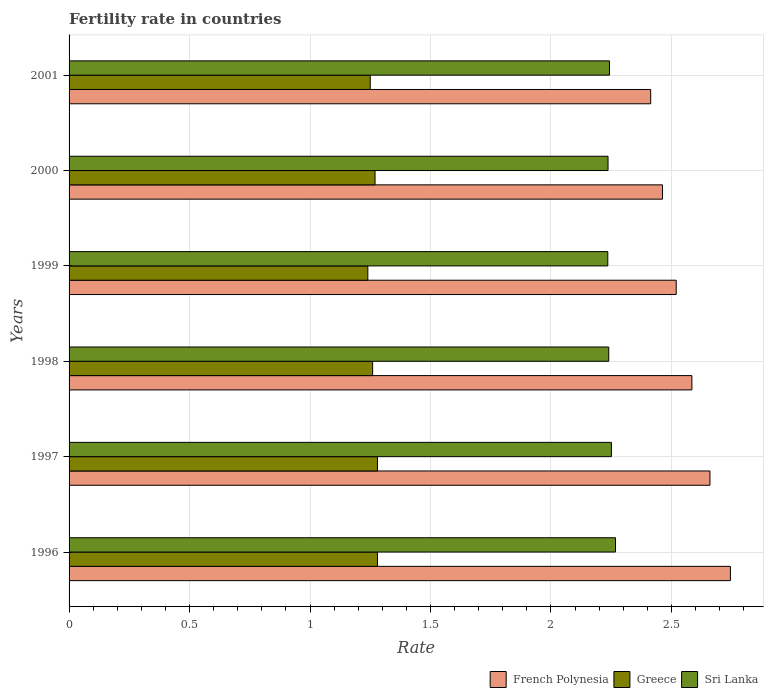Are the number of bars on each tick of the Y-axis equal?
Your answer should be compact. Yes. How many bars are there on the 4th tick from the bottom?
Make the answer very short. 3. What is the label of the 6th group of bars from the top?
Provide a succinct answer. 1996. In how many cases, is the number of bars for a given year not equal to the number of legend labels?
Your answer should be compact. 0. What is the fertility rate in French Polynesia in 1999?
Make the answer very short. 2.52. Across all years, what is the maximum fertility rate in Sri Lanka?
Offer a very short reply. 2.27. Across all years, what is the minimum fertility rate in French Polynesia?
Provide a succinct answer. 2.41. In which year was the fertility rate in Sri Lanka maximum?
Your answer should be very brief. 1996. What is the total fertility rate in Sri Lanka in the graph?
Your answer should be compact. 13.48. What is the difference between the fertility rate in Greece in 1997 and that in 2001?
Your response must be concise. 0.03. What is the difference between the fertility rate in Sri Lanka in 1996 and the fertility rate in French Polynesia in 1999?
Your answer should be compact. -0.25. What is the average fertility rate in Sri Lanka per year?
Your response must be concise. 2.25. In the year 1999, what is the difference between the fertility rate in French Polynesia and fertility rate in Greece?
Provide a succinct answer. 1.28. In how many years, is the fertility rate in French Polynesia greater than 1 ?
Keep it short and to the point. 6. What is the ratio of the fertility rate in French Polynesia in 1996 to that in 2001?
Provide a short and direct response. 1.14. Is the difference between the fertility rate in French Polynesia in 1997 and 2001 greater than the difference between the fertility rate in Greece in 1997 and 2001?
Offer a terse response. Yes. What is the difference between the highest and the second highest fertility rate in Greece?
Keep it short and to the point. 0. What is the difference between the highest and the lowest fertility rate in Greece?
Ensure brevity in your answer.  0.04. What does the 2nd bar from the top in 1997 represents?
Offer a terse response. Greece. What does the 3rd bar from the bottom in 1998 represents?
Your response must be concise. Sri Lanka. Are all the bars in the graph horizontal?
Offer a terse response. Yes. Does the graph contain any zero values?
Offer a very short reply. No. Does the graph contain grids?
Make the answer very short. Yes. How many legend labels are there?
Your answer should be compact. 3. What is the title of the graph?
Give a very brief answer. Fertility rate in countries. What is the label or title of the X-axis?
Make the answer very short. Rate. What is the label or title of the Y-axis?
Your answer should be compact. Years. What is the Rate in French Polynesia in 1996?
Your answer should be compact. 2.75. What is the Rate of Greece in 1996?
Provide a succinct answer. 1.28. What is the Rate of Sri Lanka in 1996?
Provide a short and direct response. 2.27. What is the Rate of French Polynesia in 1997?
Ensure brevity in your answer.  2.66. What is the Rate in Greece in 1997?
Provide a short and direct response. 1.28. What is the Rate of Sri Lanka in 1997?
Offer a very short reply. 2.25. What is the Rate in French Polynesia in 1998?
Provide a succinct answer. 2.58. What is the Rate of Greece in 1998?
Ensure brevity in your answer.  1.26. What is the Rate in Sri Lanka in 1998?
Give a very brief answer. 2.24. What is the Rate in French Polynesia in 1999?
Your answer should be compact. 2.52. What is the Rate of Greece in 1999?
Your answer should be compact. 1.24. What is the Rate in Sri Lanka in 1999?
Keep it short and to the point. 2.24. What is the Rate in French Polynesia in 2000?
Make the answer very short. 2.46. What is the Rate in Greece in 2000?
Provide a succinct answer. 1.27. What is the Rate in Sri Lanka in 2000?
Provide a short and direct response. 2.24. What is the Rate in French Polynesia in 2001?
Give a very brief answer. 2.41. What is the Rate of Greece in 2001?
Make the answer very short. 1.25. What is the Rate in Sri Lanka in 2001?
Keep it short and to the point. 2.24. Across all years, what is the maximum Rate of French Polynesia?
Your response must be concise. 2.75. Across all years, what is the maximum Rate of Greece?
Offer a very short reply. 1.28. Across all years, what is the maximum Rate in Sri Lanka?
Ensure brevity in your answer.  2.27. Across all years, what is the minimum Rate in French Polynesia?
Your response must be concise. 2.41. Across all years, what is the minimum Rate of Greece?
Your response must be concise. 1.24. Across all years, what is the minimum Rate of Sri Lanka?
Your response must be concise. 2.24. What is the total Rate in French Polynesia in the graph?
Provide a succinct answer. 15.39. What is the total Rate in Greece in the graph?
Offer a very short reply. 7.58. What is the total Rate in Sri Lanka in the graph?
Keep it short and to the point. 13.47. What is the difference between the Rate in French Polynesia in 1996 and that in 1997?
Your answer should be very brief. 0.09. What is the difference between the Rate of Sri Lanka in 1996 and that in 1997?
Your answer should be compact. 0.02. What is the difference between the Rate of French Polynesia in 1996 and that in 1998?
Offer a very short reply. 0.16. What is the difference between the Rate in Sri Lanka in 1996 and that in 1998?
Ensure brevity in your answer.  0.03. What is the difference between the Rate of French Polynesia in 1996 and that in 1999?
Offer a very short reply. 0.23. What is the difference between the Rate in Sri Lanka in 1996 and that in 1999?
Make the answer very short. 0.03. What is the difference between the Rate of French Polynesia in 1996 and that in 2000?
Your answer should be very brief. 0.28. What is the difference between the Rate of Greece in 1996 and that in 2000?
Your answer should be very brief. 0.01. What is the difference between the Rate in Sri Lanka in 1996 and that in 2000?
Offer a very short reply. 0.03. What is the difference between the Rate of French Polynesia in 1996 and that in 2001?
Offer a terse response. 0.33. What is the difference between the Rate in Greece in 1996 and that in 2001?
Your response must be concise. 0.03. What is the difference between the Rate of Sri Lanka in 1996 and that in 2001?
Your response must be concise. 0.03. What is the difference between the Rate of French Polynesia in 1997 and that in 1998?
Give a very brief answer. 0.07. What is the difference between the Rate in Greece in 1997 and that in 1998?
Keep it short and to the point. 0.02. What is the difference between the Rate in Sri Lanka in 1997 and that in 1998?
Your answer should be compact. 0.01. What is the difference between the Rate in French Polynesia in 1997 and that in 1999?
Your answer should be very brief. 0.14. What is the difference between the Rate of Sri Lanka in 1997 and that in 1999?
Offer a very short reply. 0.01. What is the difference between the Rate in French Polynesia in 1997 and that in 2000?
Provide a short and direct response. 0.2. What is the difference between the Rate in Greece in 1997 and that in 2000?
Provide a succinct answer. 0.01. What is the difference between the Rate in Sri Lanka in 1997 and that in 2000?
Ensure brevity in your answer.  0.01. What is the difference between the Rate in French Polynesia in 1997 and that in 2001?
Your answer should be compact. 0.25. What is the difference between the Rate in Greece in 1997 and that in 2001?
Give a very brief answer. 0.03. What is the difference between the Rate in Sri Lanka in 1997 and that in 2001?
Your answer should be very brief. 0.01. What is the difference between the Rate in French Polynesia in 1998 and that in 1999?
Give a very brief answer. 0.07. What is the difference between the Rate in Greece in 1998 and that in 1999?
Your answer should be very brief. 0.02. What is the difference between the Rate of Sri Lanka in 1998 and that in 1999?
Offer a very short reply. 0. What is the difference between the Rate in French Polynesia in 1998 and that in 2000?
Offer a very short reply. 0.12. What is the difference between the Rate of Greece in 1998 and that in 2000?
Ensure brevity in your answer.  -0.01. What is the difference between the Rate of Sri Lanka in 1998 and that in 2000?
Make the answer very short. 0. What is the difference between the Rate of French Polynesia in 1998 and that in 2001?
Your answer should be very brief. 0.17. What is the difference between the Rate in Greece in 1998 and that in 2001?
Offer a terse response. 0.01. What is the difference between the Rate in Sri Lanka in 1998 and that in 2001?
Your answer should be compact. -0. What is the difference between the Rate in French Polynesia in 1999 and that in 2000?
Your response must be concise. 0.06. What is the difference between the Rate of Greece in 1999 and that in 2000?
Provide a short and direct response. -0.03. What is the difference between the Rate of Sri Lanka in 1999 and that in 2000?
Offer a terse response. -0. What is the difference between the Rate of French Polynesia in 1999 and that in 2001?
Keep it short and to the point. 0.11. What is the difference between the Rate of Greece in 1999 and that in 2001?
Give a very brief answer. -0.01. What is the difference between the Rate in Sri Lanka in 1999 and that in 2001?
Your answer should be compact. -0.01. What is the difference between the Rate in French Polynesia in 2000 and that in 2001?
Make the answer very short. 0.05. What is the difference between the Rate of Greece in 2000 and that in 2001?
Give a very brief answer. 0.02. What is the difference between the Rate of Sri Lanka in 2000 and that in 2001?
Provide a succinct answer. -0.01. What is the difference between the Rate in French Polynesia in 1996 and the Rate in Greece in 1997?
Your response must be concise. 1.47. What is the difference between the Rate of French Polynesia in 1996 and the Rate of Sri Lanka in 1997?
Give a very brief answer. 0.49. What is the difference between the Rate in Greece in 1996 and the Rate in Sri Lanka in 1997?
Offer a terse response. -0.97. What is the difference between the Rate in French Polynesia in 1996 and the Rate in Greece in 1998?
Give a very brief answer. 1.49. What is the difference between the Rate in French Polynesia in 1996 and the Rate in Sri Lanka in 1998?
Your response must be concise. 0.51. What is the difference between the Rate of Greece in 1996 and the Rate of Sri Lanka in 1998?
Your response must be concise. -0.96. What is the difference between the Rate in French Polynesia in 1996 and the Rate in Greece in 1999?
Make the answer very short. 1.5. What is the difference between the Rate in French Polynesia in 1996 and the Rate in Sri Lanka in 1999?
Offer a terse response. 0.51. What is the difference between the Rate of Greece in 1996 and the Rate of Sri Lanka in 1999?
Your response must be concise. -0.96. What is the difference between the Rate in French Polynesia in 1996 and the Rate in Greece in 2000?
Give a very brief answer. 1.48. What is the difference between the Rate in French Polynesia in 1996 and the Rate in Sri Lanka in 2000?
Provide a short and direct response. 0.51. What is the difference between the Rate of Greece in 1996 and the Rate of Sri Lanka in 2000?
Provide a succinct answer. -0.96. What is the difference between the Rate in French Polynesia in 1996 and the Rate in Greece in 2001?
Your answer should be very brief. 1.5. What is the difference between the Rate in French Polynesia in 1996 and the Rate in Sri Lanka in 2001?
Your response must be concise. 0.5. What is the difference between the Rate of Greece in 1996 and the Rate of Sri Lanka in 2001?
Your answer should be compact. -0.96. What is the difference between the Rate in French Polynesia in 1997 and the Rate in Greece in 1998?
Keep it short and to the point. 1.4. What is the difference between the Rate of French Polynesia in 1997 and the Rate of Sri Lanka in 1998?
Provide a short and direct response. 0.42. What is the difference between the Rate of Greece in 1997 and the Rate of Sri Lanka in 1998?
Make the answer very short. -0.96. What is the difference between the Rate of French Polynesia in 1997 and the Rate of Greece in 1999?
Your response must be concise. 1.42. What is the difference between the Rate of French Polynesia in 1997 and the Rate of Sri Lanka in 1999?
Give a very brief answer. 0.42. What is the difference between the Rate in Greece in 1997 and the Rate in Sri Lanka in 1999?
Your response must be concise. -0.96. What is the difference between the Rate in French Polynesia in 1997 and the Rate in Greece in 2000?
Your answer should be very brief. 1.39. What is the difference between the Rate in French Polynesia in 1997 and the Rate in Sri Lanka in 2000?
Your response must be concise. 0.42. What is the difference between the Rate of Greece in 1997 and the Rate of Sri Lanka in 2000?
Your answer should be compact. -0.96. What is the difference between the Rate in French Polynesia in 1997 and the Rate in Greece in 2001?
Provide a succinct answer. 1.41. What is the difference between the Rate in French Polynesia in 1997 and the Rate in Sri Lanka in 2001?
Make the answer very short. 0.42. What is the difference between the Rate of Greece in 1997 and the Rate of Sri Lanka in 2001?
Make the answer very short. -0.96. What is the difference between the Rate of French Polynesia in 1998 and the Rate of Greece in 1999?
Provide a short and direct response. 1.34. What is the difference between the Rate of French Polynesia in 1998 and the Rate of Sri Lanka in 1999?
Offer a very short reply. 0.35. What is the difference between the Rate in Greece in 1998 and the Rate in Sri Lanka in 1999?
Offer a very short reply. -0.98. What is the difference between the Rate in French Polynesia in 1998 and the Rate in Greece in 2000?
Make the answer very short. 1.31. What is the difference between the Rate of French Polynesia in 1998 and the Rate of Sri Lanka in 2000?
Offer a very short reply. 0.35. What is the difference between the Rate of Greece in 1998 and the Rate of Sri Lanka in 2000?
Your answer should be very brief. -0.98. What is the difference between the Rate in French Polynesia in 1998 and the Rate in Greece in 2001?
Provide a succinct answer. 1.33. What is the difference between the Rate in French Polynesia in 1998 and the Rate in Sri Lanka in 2001?
Keep it short and to the point. 0.34. What is the difference between the Rate in Greece in 1998 and the Rate in Sri Lanka in 2001?
Offer a very short reply. -0.98. What is the difference between the Rate in French Polynesia in 1999 and the Rate in Greece in 2000?
Provide a short and direct response. 1.25. What is the difference between the Rate in French Polynesia in 1999 and the Rate in Sri Lanka in 2000?
Offer a terse response. 0.28. What is the difference between the Rate in Greece in 1999 and the Rate in Sri Lanka in 2000?
Ensure brevity in your answer.  -1. What is the difference between the Rate of French Polynesia in 1999 and the Rate of Greece in 2001?
Offer a terse response. 1.27. What is the difference between the Rate in French Polynesia in 1999 and the Rate in Sri Lanka in 2001?
Your answer should be very brief. 0.28. What is the difference between the Rate in Greece in 1999 and the Rate in Sri Lanka in 2001?
Offer a very short reply. -1. What is the difference between the Rate of French Polynesia in 2000 and the Rate of Greece in 2001?
Keep it short and to the point. 1.21. What is the difference between the Rate in French Polynesia in 2000 and the Rate in Sri Lanka in 2001?
Offer a very short reply. 0.22. What is the difference between the Rate of Greece in 2000 and the Rate of Sri Lanka in 2001?
Your answer should be very brief. -0.97. What is the average Rate in French Polynesia per year?
Offer a very short reply. 2.56. What is the average Rate of Greece per year?
Offer a very short reply. 1.26. What is the average Rate in Sri Lanka per year?
Make the answer very short. 2.25. In the year 1996, what is the difference between the Rate in French Polynesia and Rate in Greece?
Make the answer very short. 1.47. In the year 1996, what is the difference between the Rate of French Polynesia and Rate of Sri Lanka?
Your response must be concise. 0.48. In the year 1996, what is the difference between the Rate of Greece and Rate of Sri Lanka?
Offer a terse response. -0.99. In the year 1997, what is the difference between the Rate of French Polynesia and Rate of Greece?
Offer a very short reply. 1.38. In the year 1997, what is the difference between the Rate in French Polynesia and Rate in Sri Lanka?
Provide a succinct answer. 0.41. In the year 1997, what is the difference between the Rate in Greece and Rate in Sri Lanka?
Offer a terse response. -0.97. In the year 1998, what is the difference between the Rate of French Polynesia and Rate of Greece?
Offer a very short reply. 1.32. In the year 1998, what is the difference between the Rate of French Polynesia and Rate of Sri Lanka?
Your answer should be very brief. 0.34. In the year 1998, what is the difference between the Rate in Greece and Rate in Sri Lanka?
Give a very brief answer. -0.98. In the year 1999, what is the difference between the Rate in French Polynesia and Rate in Greece?
Give a very brief answer. 1.28. In the year 1999, what is the difference between the Rate of French Polynesia and Rate of Sri Lanka?
Your response must be concise. 0.28. In the year 1999, what is the difference between the Rate of Greece and Rate of Sri Lanka?
Offer a terse response. -1. In the year 2000, what is the difference between the Rate of French Polynesia and Rate of Greece?
Your response must be concise. 1.19. In the year 2000, what is the difference between the Rate of French Polynesia and Rate of Sri Lanka?
Provide a succinct answer. 0.23. In the year 2000, what is the difference between the Rate of Greece and Rate of Sri Lanka?
Provide a succinct answer. -0.97. In the year 2001, what is the difference between the Rate of French Polynesia and Rate of Greece?
Provide a short and direct response. 1.16. In the year 2001, what is the difference between the Rate of French Polynesia and Rate of Sri Lanka?
Ensure brevity in your answer.  0.17. In the year 2001, what is the difference between the Rate in Greece and Rate in Sri Lanka?
Ensure brevity in your answer.  -0.99. What is the ratio of the Rate in French Polynesia in 1996 to that in 1997?
Give a very brief answer. 1.03. What is the ratio of the Rate of Greece in 1996 to that in 1997?
Your response must be concise. 1. What is the ratio of the Rate in Sri Lanka in 1996 to that in 1997?
Offer a terse response. 1.01. What is the ratio of the Rate in French Polynesia in 1996 to that in 1998?
Ensure brevity in your answer.  1.06. What is the ratio of the Rate of Greece in 1996 to that in 1998?
Provide a short and direct response. 1.02. What is the ratio of the Rate in Sri Lanka in 1996 to that in 1998?
Your answer should be very brief. 1.01. What is the ratio of the Rate in French Polynesia in 1996 to that in 1999?
Your answer should be very brief. 1.09. What is the ratio of the Rate of Greece in 1996 to that in 1999?
Offer a terse response. 1.03. What is the ratio of the Rate in Sri Lanka in 1996 to that in 1999?
Keep it short and to the point. 1.01. What is the ratio of the Rate of French Polynesia in 1996 to that in 2000?
Your answer should be compact. 1.11. What is the ratio of the Rate in Greece in 1996 to that in 2000?
Your response must be concise. 1.01. What is the ratio of the Rate in Sri Lanka in 1996 to that in 2000?
Provide a short and direct response. 1.01. What is the ratio of the Rate in French Polynesia in 1996 to that in 2001?
Offer a very short reply. 1.14. What is the ratio of the Rate in Greece in 1996 to that in 2001?
Ensure brevity in your answer.  1.02. What is the ratio of the Rate of Sri Lanka in 1996 to that in 2001?
Provide a short and direct response. 1.01. What is the ratio of the Rate of French Polynesia in 1997 to that in 1998?
Offer a very short reply. 1.03. What is the ratio of the Rate of Greece in 1997 to that in 1998?
Provide a short and direct response. 1.02. What is the ratio of the Rate in Sri Lanka in 1997 to that in 1998?
Provide a succinct answer. 1. What is the ratio of the Rate of French Polynesia in 1997 to that in 1999?
Keep it short and to the point. 1.06. What is the ratio of the Rate in Greece in 1997 to that in 1999?
Keep it short and to the point. 1.03. What is the ratio of the Rate of Sri Lanka in 1997 to that in 1999?
Give a very brief answer. 1.01. What is the ratio of the Rate in French Polynesia in 1997 to that in 2000?
Make the answer very short. 1.08. What is the ratio of the Rate in Greece in 1997 to that in 2000?
Your answer should be compact. 1.01. What is the ratio of the Rate in French Polynesia in 1997 to that in 2001?
Provide a short and direct response. 1.1. What is the ratio of the Rate in Greece in 1997 to that in 2001?
Keep it short and to the point. 1.02. What is the ratio of the Rate in French Polynesia in 1998 to that in 1999?
Make the answer very short. 1.03. What is the ratio of the Rate of Greece in 1998 to that in 1999?
Your response must be concise. 1.02. What is the ratio of the Rate of Sri Lanka in 1998 to that in 1999?
Provide a short and direct response. 1. What is the ratio of the Rate of French Polynesia in 1998 to that in 2000?
Your answer should be compact. 1.05. What is the ratio of the Rate in Sri Lanka in 1998 to that in 2000?
Provide a succinct answer. 1. What is the ratio of the Rate in French Polynesia in 1998 to that in 2001?
Your response must be concise. 1.07. What is the ratio of the Rate in French Polynesia in 1999 to that in 2000?
Provide a short and direct response. 1.02. What is the ratio of the Rate in Greece in 1999 to that in 2000?
Ensure brevity in your answer.  0.98. What is the ratio of the Rate of Sri Lanka in 1999 to that in 2000?
Your answer should be compact. 1. What is the ratio of the Rate in French Polynesia in 1999 to that in 2001?
Offer a terse response. 1.04. What is the ratio of the Rate of Greece in 1999 to that in 2001?
Ensure brevity in your answer.  0.99. What is the ratio of the Rate in French Polynesia in 2000 to that in 2001?
Make the answer very short. 1.02. What is the difference between the highest and the second highest Rate in French Polynesia?
Offer a terse response. 0.09. What is the difference between the highest and the second highest Rate in Sri Lanka?
Make the answer very short. 0.02. What is the difference between the highest and the lowest Rate in French Polynesia?
Provide a short and direct response. 0.33. What is the difference between the highest and the lowest Rate of Sri Lanka?
Make the answer very short. 0.03. 